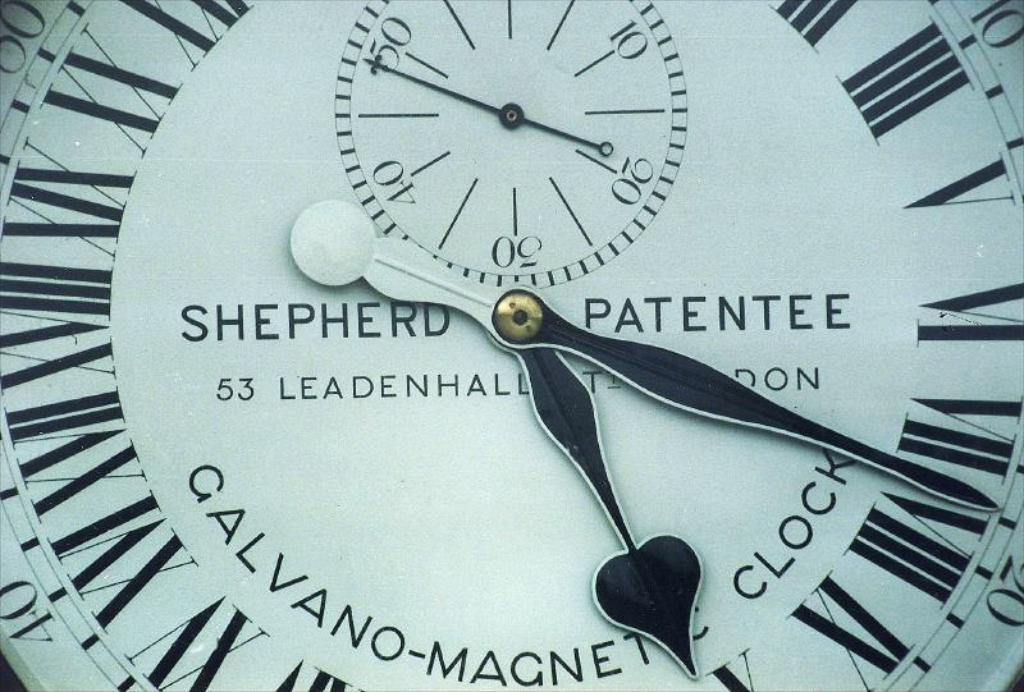What object in the image tells time? There is a clock in the image that tells time. What type of numerals are used on the clock? The clock has roman letters and numbers. What are the main components of the clock? The clock has numbers and clock needles. What type of cakes are being served in the morning in the image? There are no cakes or references to morning in the image; it only features a clock. 